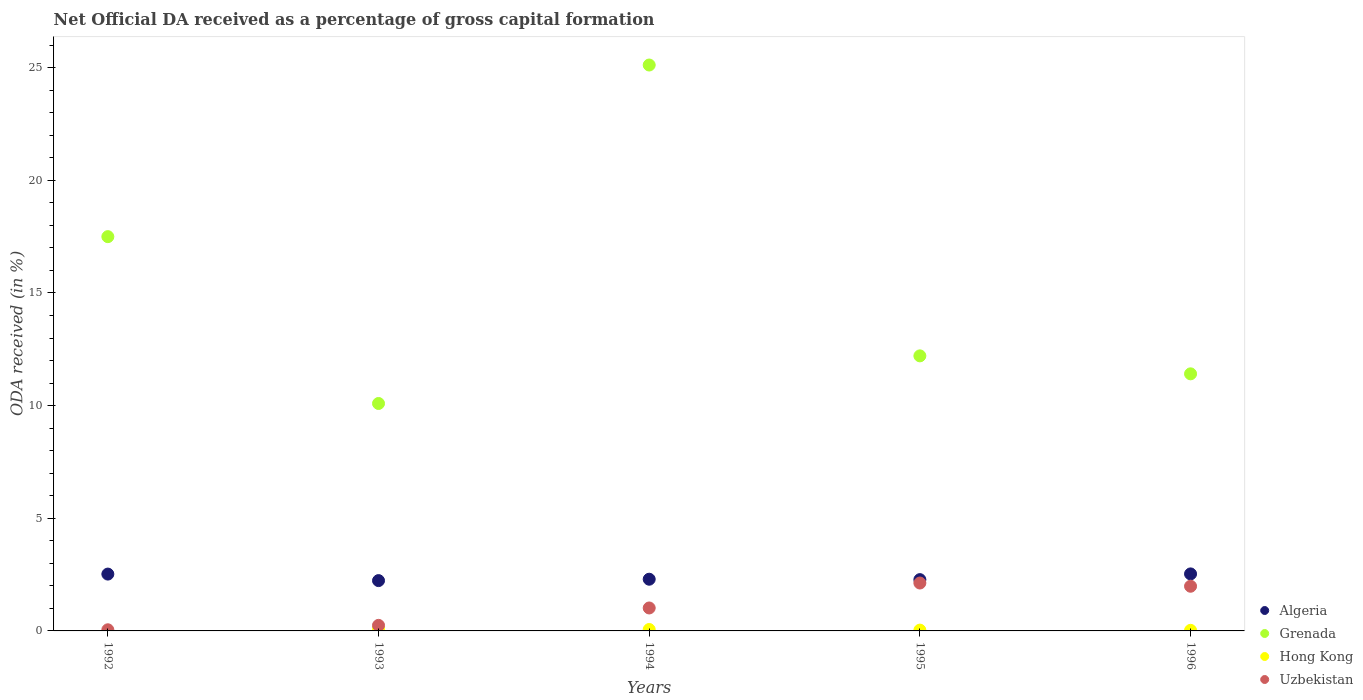Is the number of dotlines equal to the number of legend labels?
Your answer should be compact. No. What is the net ODA received in Uzbekistan in 1994?
Your response must be concise. 1.02. Across all years, what is the maximum net ODA received in Grenada?
Keep it short and to the point. 25.12. Across all years, what is the minimum net ODA received in Grenada?
Offer a terse response. 10.09. In which year was the net ODA received in Hong Kong maximum?
Give a very brief answer. 1993. What is the total net ODA received in Hong Kong in the graph?
Your answer should be compact. 0.22. What is the difference between the net ODA received in Uzbekistan in 1992 and that in 1995?
Provide a short and direct response. -2.08. What is the difference between the net ODA received in Grenada in 1993 and the net ODA received in Hong Kong in 1996?
Make the answer very short. 10.07. What is the average net ODA received in Uzbekistan per year?
Offer a very short reply. 1.08. In the year 1995, what is the difference between the net ODA received in Grenada and net ODA received in Uzbekistan?
Ensure brevity in your answer.  10.08. In how many years, is the net ODA received in Algeria greater than 25 %?
Your answer should be compact. 0. What is the ratio of the net ODA received in Grenada in 1992 to that in 1994?
Keep it short and to the point. 0.7. Is the net ODA received in Algeria in 1995 less than that in 1996?
Provide a succinct answer. Yes. Is the difference between the net ODA received in Grenada in 1993 and 1996 greater than the difference between the net ODA received in Uzbekistan in 1993 and 1996?
Give a very brief answer. Yes. What is the difference between the highest and the second highest net ODA received in Uzbekistan?
Offer a terse response. 0.14. What is the difference between the highest and the lowest net ODA received in Uzbekistan?
Make the answer very short. 2.08. Is the sum of the net ODA received in Uzbekistan in 1993 and 1995 greater than the maximum net ODA received in Hong Kong across all years?
Ensure brevity in your answer.  Yes. Is it the case that in every year, the sum of the net ODA received in Algeria and net ODA received in Hong Kong  is greater than the sum of net ODA received in Uzbekistan and net ODA received in Grenada?
Keep it short and to the point. Yes. Is it the case that in every year, the sum of the net ODA received in Algeria and net ODA received in Grenada  is greater than the net ODA received in Hong Kong?
Offer a very short reply. Yes. Is the net ODA received in Algeria strictly greater than the net ODA received in Grenada over the years?
Keep it short and to the point. No. How many years are there in the graph?
Your response must be concise. 5. What is the difference between two consecutive major ticks on the Y-axis?
Offer a very short reply. 5. Are the values on the major ticks of Y-axis written in scientific E-notation?
Keep it short and to the point. No. Does the graph contain any zero values?
Make the answer very short. Yes. What is the title of the graph?
Give a very brief answer. Net Official DA received as a percentage of gross capital formation. What is the label or title of the X-axis?
Make the answer very short. Years. What is the label or title of the Y-axis?
Your answer should be compact. ODA received (in %). What is the ODA received (in %) in Algeria in 1992?
Give a very brief answer. 2.52. What is the ODA received (in %) in Grenada in 1992?
Give a very brief answer. 17.5. What is the ODA received (in %) in Uzbekistan in 1992?
Ensure brevity in your answer.  0.05. What is the ODA received (in %) in Algeria in 1993?
Your response must be concise. 2.23. What is the ODA received (in %) of Grenada in 1993?
Your answer should be compact. 10.09. What is the ODA received (in %) in Hong Kong in 1993?
Make the answer very short. 0.09. What is the ODA received (in %) of Uzbekistan in 1993?
Give a very brief answer. 0.25. What is the ODA received (in %) in Algeria in 1994?
Ensure brevity in your answer.  2.29. What is the ODA received (in %) in Grenada in 1994?
Make the answer very short. 25.12. What is the ODA received (in %) in Hong Kong in 1994?
Ensure brevity in your answer.  0.06. What is the ODA received (in %) of Uzbekistan in 1994?
Ensure brevity in your answer.  1.02. What is the ODA received (in %) of Algeria in 1995?
Keep it short and to the point. 2.28. What is the ODA received (in %) in Grenada in 1995?
Ensure brevity in your answer.  12.21. What is the ODA received (in %) in Hong Kong in 1995?
Keep it short and to the point. 0.04. What is the ODA received (in %) in Uzbekistan in 1995?
Offer a terse response. 2.13. What is the ODA received (in %) of Algeria in 1996?
Give a very brief answer. 2.53. What is the ODA received (in %) in Grenada in 1996?
Give a very brief answer. 11.41. What is the ODA received (in %) of Hong Kong in 1996?
Ensure brevity in your answer.  0.03. What is the ODA received (in %) of Uzbekistan in 1996?
Provide a succinct answer. 1.98. Across all years, what is the maximum ODA received (in %) of Algeria?
Make the answer very short. 2.53. Across all years, what is the maximum ODA received (in %) of Grenada?
Your answer should be very brief. 25.12. Across all years, what is the maximum ODA received (in %) of Hong Kong?
Provide a short and direct response. 0.09. Across all years, what is the maximum ODA received (in %) in Uzbekistan?
Your answer should be very brief. 2.13. Across all years, what is the minimum ODA received (in %) of Algeria?
Keep it short and to the point. 2.23. Across all years, what is the minimum ODA received (in %) of Grenada?
Provide a succinct answer. 10.09. Across all years, what is the minimum ODA received (in %) in Hong Kong?
Keep it short and to the point. 0. Across all years, what is the minimum ODA received (in %) in Uzbekistan?
Ensure brevity in your answer.  0.05. What is the total ODA received (in %) of Algeria in the graph?
Provide a short and direct response. 11.86. What is the total ODA received (in %) of Grenada in the graph?
Your answer should be compact. 76.33. What is the total ODA received (in %) of Hong Kong in the graph?
Keep it short and to the point. 0.22. What is the total ODA received (in %) in Uzbekistan in the graph?
Provide a short and direct response. 5.42. What is the difference between the ODA received (in %) of Algeria in 1992 and that in 1993?
Your answer should be very brief. 0.29. What is the difference between the ODA received (in %) in Grenada in 1992 and that in 1993?
Your answer should be compact. 7.4. What is the difference between the ODA received (in %) in Uzbekistan in 1992 and that in 1993?
Give a very brief answer. -0.2. What is the difference between the ODA received (in %) of Algeria in 1992 and that in 1994?
Keep it short and to the point. 0.23. What is the difference between the ODA received (in %) in Grenada in 1992 and that in 1994?
Give a very brief answer. -7.62. What is the difference between the ODA received (in %) of Uzbekistan in 1992 and that in 1994?
Provide a short and direct response. -0.97. What is the difference between the ODA received (in %) in Algeria in 1992 and that in 1995?
Keep it short and to the point. 0.25. What is the difference between the ODA received (in %) in Grenada in 1992 and that in 1995?
Offer a very short reply. 5.29. What is the difference between the ODA received (in %) in Uzbekistan in 1992 and that in 1995?
Make the answer very short. -2.08. What is the difference between the ODA received (in %) of Algeria in 1992 and that in 1996?
Provide a short and direct response. -0.01. What is the difference between the ODA received (in %) of Grenada in 1992 and that in 1996?
Your response must be concise. 6.09. What is the difference between the ODA received (in %) of Uzbekistan in 1992 and that in 1996?
Your response must be concise. -1.93. What is the difference between the ODA received (in %) in Algeria in 1993 and that in 1994?
Provide a short and direct response. -0.06. What is the difference between the ODA received (in %) in Grenada in 1993 and that in 1994?
Ensure brevity in your answer.  -15.02. What is the difference between the ODA received (in %) of Hong Kong in 1993 and that in 1994?
Your response must be concise. 0.03. What is the difference between the ODA received (in %) of Uzbekistan in 1993 and that in 1994?
Your answer should be very brief. -0.77. What is the difference between the ODA received (in %) of Algeria in 1993 and that in 1995?
Your response must be concise. -0.04. What is the difference between the ODA received (in %) of Grenada in 1993 and that in 1995?
Your answer should be compact. -2.11. What is the difference between the ODA received (in %) in Hong Kong in 1993 and that in 1995?
Offer a terse response. 0.06. What is the difference between the ODA received (in %) in Uzbekistan in 1993 and that in 1995?
Keep it short and to the point. -1.88. What is the difference between the ODA received (in %) in Algeria in 1993 and that in 1996?
Ensure brevity in your answer.  -0.3. What is the difference between the ODA received (in %) in Grenada in 1993 and that in 1996?
Provide a succinct answer. -1.32. What is the difference between the ODA received (in %) in Hong Kong in 1993 and that in 1996?
Give a very brief answer. 0.07. What is the difference between the ODA received (in %) in Uzbekistan in 1993 and that in 1996?
Offer a terse response. -1.74. What is the difference between the ODA received (in %) in Algeria in 1994 and that in 1995?
Ensure brevity in your answer.  0.02. What is the difference between the ODA received (in %) in Grenada in 1994 and that in 1995?
Provide a succinct answer. 12.91. What is the difference between the ODA received (in %) of Hong Kong in 1994 and that in 1995?
Make the answer very short. 0.03. What is the difference between the ODA received (in %) of Uzbekistan in 1994 and that in 1995?
Give a very brief answer. -1.11. What is the difference between the ODA received (in %) of Algeria in 1994 and that in 1996?
Ensure brevity in your answer.  -0.24. What is the difference between the ODA received (in %) of Grenada in 1994 and that in 1996?
Make the answer very short. 13.71. What is the difference between the ODA received (in %) in Hong Kong in 1994 and that in 1996?
Your answer should be compact. 0.04. What is the difference between the ODA received (in %) of Uzbekistan in 1994 and that in 1996?
Your answer should be compact. -0.96. What is the difference between the ODA received (in %) of Algeria in 1995 and that in 1996?
Give a very brief answer. -0.25. What is the difference between the ODA received (in %) of Grenada in 1995 and that in 1996?
Your answer should be compact. 0.8. What is the difference between the ODA received (in %) of Hong Kong in 1995 and that in 1996?
Offer a terse response. 0.01. What is the difference between the ODA received (in %) of Uzbekistan in 1995 and that in 1996?
Your answer should be compact. 0.14. What is the difference between the ODA received (in %) in Algeria in 1992 and the ODA received (in %) in Grenada in 1993?
Your answer should be compact. -7.57. What is the difference between the ODA received (in %) of Algeria in 1992 and the ODA received (in %) of Hong Kong in 1993?
Ensure brevity in your answer.  2.43. What is the difference between the ODA received (in %) of Algeria in 1992 and the ODA received (in %) of Uzbekistan in 1993?
Make the answer very short. 2.28. What is the difference between the ODA received (in %) of Grenada in 1992 and the ODA received (in %) of Hong Kong in 1993?
Offer a very short reply. 17.41. What is the difference between the ODA received (in %) of Grenada in 1992 and the ODA received (in %) of Uzbekistan in 1993?
Offer a very short reply. 17.25. What is the difference between the ODA received (in %) in Algeria in 1992 and the ODA received (in %) in Grenada in 1994?
Ensure brevity in your answer.  -22.59. What is the difference between the ODA received (in %) in Algeria in 1992 and the ODA received (in %) in Hong Kong in 1994?
Ensure brevity in your answer.  2.46. What is the difference between the ODA received (in %) of Algeria in 1992 and the ODA received (in %) of Uzbekistan in 1994?
Offer a very short reply. 1.5. What is the difference between the ODA received (in %) of Grenada in 1992 and the ODA received (in %) of Hong Kong in 1994?
Offer a very short reply. 17.44. What is the difference between the ODA received (in %) in Grenada in 1992 and the ODA received (in %) in Uzbekistan in 1994?
Keep it short and to the point. 16.48. What is the difference between the ODA received (in %) of Algeria in 1992 and the ODA received (in %) of Grenada in 1995?
Keep it short and to the point. -9.69. What is the difference between the ODA received (in %) in Algeria in 1992 and the ODA received (in %) in Hong Kong in 1995?
Provide a succinct answer. 2.49. What is the difference between the ODA received (in %) of Algeria in 1992 and the ODA received (in %) of Uzbekistan in 1995?
Ensure brevity in your answer.  0.4. What is the difference between the ODA received (in %) of Grenada in 1992 and the ODA received (in %) of Hong Kong in 1995?
Provide a succinct answer. 17.46. What is the difference between the ODA received (in %) in Grenada in 1992 and the ODA received (in %) in Uzbekistan in 1995?
Give a very brief answer. 15.37. What is the difference between the ODA received (in %) in Algeria in 1992 and the ODA received (in %) in Grenada in 1996?
Ensure brevity in your answer.  -8.89. What is the difference between the ODA received (in %) of Algeria in 1992 and the ODA received (in %) of Hong Kong in 1996?
Give a very brief answer. 2.5. What is the difference between the ODA received (in %) in Algeria in 1992 and the ODA received (in %) in Uzbekistan in 1996?
Provide a short and direct response. 0.54. What is the difference between the ODA received (in %) in Grenada in 1992 and the ODA received (in %) in Hong Kong in 1996?
Offer a terse response. 17.47. What is the difference between the ODA received (in %) in Grenada in 1992 and the ODA received (in %) in Uzbekistan in 1996?
Offer a terse response. 15.52. What is the difference between the ODA received (in %) in Algeria in 1993 and the ODA received (in %) in Grenada in 1994?
Ensure brevity in your answer.  -22.88. What is the difference between the ODA received (in %) in Algeria in 1993 and the ODA received (in %) in Hong Kong in 1994?
Provide a short and direct response. 2.17. What is the difference between the ODA received (in %) of Algeria in 1993 and the ODA received (in %) of Uzbekistan in 1994?
Keep it short and to the point. 1.21. What is the difference between the ODA received (in %) in Grenada in 1993 and the ODA received (in %) in Hong Kong in 1994?
Your response must be concise. 10.03. What is the difference between the ODA received (in %) in Grenada in 1993 and the ODA received (in %) in Uzbekistan in 1994?
Keep it short and to the point. 9.08. What is the difference between the ODA received (in %) of Hong Kong in 1993 and the ODA received (in %) of Uzbekistan in 1994?
Provide a short and direct response. -0.93. What is the difference between the ODA received (in %) of Algeria in 1993 and the ODA received (in %) of Grenada in 1995?
Give a very brief answer. -9.97. What is the difference between the ODA received (in %) in Algeria in 1993 and the ODA received (in %) in Hong Kong in 1995?
Make the answer very short. 2.2. What is the difference between the ODA received (in %) in Algeria in 1993 and the ODA received (in %) in Uzbekistan in 1995?
Ensure brevity in your answer.  0.11. What is the difference between the ODA received (in %) of Grenada in 1993 and the ODA received (in %) of Hong Kong in 1995?
Offer a terse response. 10.06. What is the difference between the ODA received (in %) of Grenada in 1993 and the ODA received (in %) of Uzbekistan in 1995?
Keep it short and to the point. 7.97. What is the difference between the ODA received (in %) of Hong Kong in 1993 and the ODA received (in %) of Uzbekistan in 1995?
Provide a succinct answer. -2.03. What is the difference between the ODA received (in %) in Algeria in 1993 and the ODA received (in %) in Grenada in 1996?
Your answer should be very brief. -9.18. What is the difference between the ODA received (in %) of Algeria in 1993 and the ODA received (in %) of Hong Kong in 1996?
Make the answer very short. 2.21. What is the difference between the ODA received (in %) in Grenada in 1993 and the ODA received (in %) in Hong Kong in 1996?
Give a very brief answer. 10.07. What is the difference between the ODA received (in %) in Grenada in 1993 and the ODA received (in %) in Uzbekistan in 1996?
Keep it short and to the point. 8.11. What is the difference between the ODA received (in %) in Hong Kong in 1993 and the ODA received (in %) in Uzbekistan in 1996?
Provide a succinct answer. -1.89. What is the difference between the ODA received (in %) in Algeria in 1994 and the ODA received (in %) in Grenada in 1995?
Ensure brevity in your answer.  -9.91. What is the difference between the ODA received (in %) in Algeria in 1994 and the ODA received (in %) in Hong Kong in 1995?
Your response must be concise. 2.26. What is the difference between the ODA received (in %) in Algeria in 1994 and the ODA received (in %) in Uzbekistan in 1995?
Your answer should be very brief. 0.17. What is the difference between the ODA received (in %) in Grenada in 1994 and the ODA received (in %) in Hong Kong in 1995?
Give a very brief answer. 25.08. What is the difference between the ODA received (in %) in Grenada in 1994 and the ODA received (in %) in Uzbekistan in 1995?
Your answer should be compact. 22.99. What is the difference between the ODA received (in %) of Hong Kong in 1994 and the ODA received (in %) of Uzbekistan in 1995?
Offer a very short reply. -2.06. What is the difference between the ODA received (in %) of Algeria in 1994 and the ODA received (in %) of Grenada in 1996?
Provide a short and direct response. -9.12. What is the difference between the ODA received (in %) in Algeria in 1994 and the ODA received (in %) in Hong Kong in 1996?
Make the answer very short. 2.27. What is the difference between the ODA received (in %) of Algeria in 1994 and the ODA received (in %) of Uzbekistan in 1996?
Keep it short and to the point. 0.31. What is the difference between the ODA received (in %) in Grenada in 1994 and the ODA received (in %) in Hong Kong in 1996?
Your response must be concise. 25.09. What is the difference between the ODA received (in %) of Grenada in 1994 and the ODA received (in %) of Uzbekistan in 1996?
Give a very brief answer. 23.13. What is the difference between the ODA received (in %) of Hong Kong in 1994 and the ODA received (in %) of Uzbekistan in 1996?
Give a very brief answer. -1.92. What is the difference between the ODA received (in %) of Algeria in 1995 and the ODA received (in %) of Grenada in 1996?
Provide a short and direct response. -9.13. What is the difference between the ODA received (in %) of Algeria in 1995 and the ODA received (in %) of Hong Kong in 1996?
Offer a terse response. 2.25. What is the difference between the ODA received (in %) in Algeria in 1995 and the ODA received (in %) in Uzbekistan in 1996?
Provide a succinct answer. 0.29. What is the difference between the ODA received (in %) of Grenada in 1995 and the ODA received (in %) of Hong Kong in 1996?
Offer a terse response. 12.18. What is the difference between the ODA received (in %) of Grenada in 1995 and the ODA received (in %) of Uzbekistan in 1996?
Keep it short and to the point. 10.22. What is the difference between the ODA received (in %) of Hong Kong in 1995 and the ODA received (in %) of Uzbekistan in 1996?
Your answer should be compact. -1.95. What is the average ODA received (in %) in Algeria per year?
Make the answer very short. 2.37. What is the average ODA received (in %) in Grenada per year?
Ensure brevity in your answer.  15.27. What is the average ODA received (in %) in Hong Kong per year?
Provide a succinct answer. 0.04. What is the average ODA received (in %) of Uzbekistan per year?
Provide a short and direct response. 1.08. In the year 1992, what is the difference between the ODA received (in %) in Algeria and ODA received (in %) in Grenada?
Provide a short and direct response. -14.98. In the year 1992, what is the difference between the ODA received (in %) of Algeria and ODA received (in %) of Uzbekistan?
Give a very brief answer. 2.47. In the year 1992, what is the difference between the ODA received (in %) in Grenada and ODA received (in %) in Uzbekistan?
Offer a very short reply. 17.45. In the year 1993, what is the difference between the ODA received (in %) in Algeria and ODA received (in %) in Grenada?
Ensure brevity in your answer.  -7.86. In the year 1993, what is the difference between the ODA received (in %) in Algeria and ODA received (in %) in Hong Kong?
Your answer should be very brief. 2.14. In the year 1993, what is the difference between the ODA received (in %) of Algeria and ODA received (in %) of Uzbekistan?
Give a very brief answer. 1.99. In the year 1993, what is the difference between the ODA received (in %) in Grenada and ODA received (in %) in Hong Kong?
Ensure brevity in your answer.  10. In the year 1993, what is the difference between the ODA received (in %) of Grenada and ODA received (in %) of Uzbekistan?
Ensure brevity in your answer.  9.85. In the year 1993, what is the difference between the ODA received (in %) in Hong Kong and ODA received (in %) in Uzbekistan?
Ensure brevity in your answer.  -0.15. In the year 1994, what is the difference between the ODA received (in %) in Algeria and ODA received (in %) in Grenada?
Your response must be concise. -22.82. In the year 1994, what is the difference between the ODA received (in %) in Algeria and ODA received (in %) in Hong Kong?
Make the answer very short. 2.23. In the year 1994, what is the difference between the ODA received (in %) in Algeria and ODA received (in %) in Uzbekistan?
Make the answer very short. 1.28. In the year 1994, what is the difference between the ODA received (in %) in Grenada and ODA received (in %) in Hong Kong?
Offer a terse response. 25.05. In the year 1994, what is the difference between the ODA received (in %) in Grenada and ODA received (in %) in Uzbekistan?
Your answer should be very brief. 24.1. In the year 1994, what is the difference between the ODA received (in %) of Hong Kong and ODA received (in %) of Uzbekistan?
Your answer should be very brief. -0.96. In the year 1995, what is the difference between the ODA received (in %) in Algeria and ODA received (in %) in Grenada?
Keep it short and to the point. -9.93. In the year 1995, what is the difference between the ODA received (in %) in Algeria and ODA received (in %) in Hong Kong?
Make the answer very short. 2.24. In the year 1995, what is the difference between the ODA received (in %) of Algeria and ODA received (in %) of Uzbekistan?
Your response must be concise. 0.15. In the year 1995, what is the difference between the ODA received (in %) of Grenada and ODA received (in %) of Hong Kong?
Offer a terse response. 12.17. In the year 1995, what is the difference between the ODA received (in %) of Grenada and ODA received (in %) of Uzbekistan?
Give a very brief answer. 10.08. In the year 1995, what is the difference between the ODA received (in %) of Hong Kong and ODA received (in %) of Uzbekistan?
Keep it short and to the point. -2.09. In the year 1996, what is the difference between the ODA received (in %) of Algeria and ODA received (in %) of Grenada?
Your response must be concise. -8.88. In the year 1996, what is the difference between the ODA received (in %) of Algeria and ODA received (in %) of Hong Kong?
Offer a very short reply. 2.5. In the year 1996, what is the difference between the ODA received (in %) of Algeria and ODA received (in %) of Uzbekistan?
Make the answer very short. 0.55. In the year 1996, what is the difference between the ODA received (in %) of Grenada and ODA received (in %) of Hong Kong?
Provide a succinct answer. 11.38. In the year 1996, what is the difference between the ODA received (in %) of Grenada and ODA received (in %) of Uzbekistan?
Provide a succinct answer. 9.43. In the year 1996, what is the difference between the ODA received (in %) in Hong Kong and ODA received (in %) in Uzbekistan?
Keep it short and to the point. -1.96. What is the ratio of the ODA received (in %) of Algeria in 1992 to that in 1993?
Offer a terse response. 1.13. What is the ratio of the ODA received (in %) of Grenada in 1992 to that in 1993?
Ensure brevity in your answer.  1.73. What is the ratio of the ODA received (in %) in Uzbekistan in 1992 to that in 1993?
Make the answer very short. 0.2. What is the ratio of the ODA received (in %) of Algeria in 1992 to that in 1994?
Provide a short and direct response. 1.1. What is the ratio of the ODA received (in %) of Grenada in 1992 to that in 1994?
Your answer should be compact. 0.7. What is the ratio of the ODA received (in %) in Uzbekistan in 1992 to that in 1994?
Provide a succinct answer. 0.05. What is the ratio of the ODA received (in %) of Algeria in 1992 to that in 1995?
Your answer should be very brief. 1.11. What is the ratio of the ODA received (in %) in Grenada in 1992 to that in 1995?
Your response must be concise. 1.43. What is the ratio of the ODA received (in %) in Uzbekistan in 1992 to that in 1995?
Give a very brief answer. 0.02. What is the ratio of the ODA received (in %) in Algeria in 1992 to that in 1996?
Offer a terse response. 1. What is the ratio of the ODA received (in %) of Grenada in 1992 to that in 1996?
Offer a very short reply. 1.53. What is the ratio of the ODA received (in %) of Uzbekistan in 1992 to that in 1996?
Make the answer very short. 0.03. What is the ratio of the ODA received (in %) of Algeria in 1993 to that in 1994?
Make the answer very short. 0.97. What is the ratio of the ODA received (in %) in Grenada in 1993 to that in 1994?
Offer a very short reply. 0.4. What is the ratio of the ODA received (in %) in Hong Kong in 1993 to that in 1994?
Your answer should be compact. 1.46. What is the ratio of the ODA received (in %) of Uzbekistan in 1993 to that in 1994?
Provide a succinct answer. 0.24. What is the ratio of the ODA received (in %) in Algeria in 1993 to that in 1995?
Provide a succinct answer. 0.98. What is the ratio of the ODA received (in %) in Grenada in 1993 to that in 1995?
Make the answer very short. 0.83. What is the ratio of the ODA received (in %) of Hong Kong in 1993 to that in 1995?
Make the answer very short. 2.58. What is the ratio of the ODA received (in %) of Uzbekistan in 1993 to that in 1995?
Provide a succinct answer. 0.12. What is the ratio of the ODA received (in %) in Algeria in 1993 to that in 1996?
Your answer should be very brief. 0.88. What is the ratio of the ODA received (in %) in Grenada in 1993 to that in 1996?
Offer a terse response. 0.88. What is the ratio of the ODA received (in %) of Hong Kong in 1993 to that in 1996?
Your response must be concise. 3.55. What is the ratio of the ODA received (in %) of Uzbekistan in 1993 to that in 1996?
Offer a very short reply. 0.12. What is the ratio of the ODA received (in %) in Algeria in 1994 to that in 1995?
Keep it short and to the point. 1.01. What is the ratio of the ODA received (in %) in Grenada in 1994 to that in 1995?
Ensure brevity in your answer.  2.06. What is the ratio of the ODA received (in %) in Hong Kong in 1994 to that in 1995?
Provide a succinct answer. 1.76. What is the ratio of the ODA received (in %) of Uzbekistan in 1994 to that in 1995?
Your response must be concise. 0.48. What is the ratio of the ODA received (in %) of Algeria in 1994 to that in 1996?
Keep it short and to the point. 0.91. What is the ratio of the ODA received (in %) in Grenada in 1994 to that in 1996?
Your response must be concise. 2.2. What is the ratio of the ODA received (in %) of Hong Kong in 1994 to that in 1996?
Keep it short and to the point. 2.43. What is the ratio of the ODA received (in %) of Uzbekistan in 1994 to that in 1996?
Offer a very short reply. 0.51. What is the ratio of the ODA received (in %) in Algeria in 1995 to that in 1996?
Provide a succinct answer. 0.9. What is the ratio of the ODA received (in %) of Grenada in 1995 to that in 1996?
Provide a short and direct response. 1.07. What is the ratio of the ODA received (in %) of Hong Kong in 1995 to that in 1996?
Keep it short and to the point. 1.38. What is the ratio of the ODA received (in %) in Uzbekistan in 1995 to that in 1996?
Provide a short and direct response. 1.07. What is the difference between the highest and the second highest ODA received (in %) in Algeria?
Offer a terse response. 0.01. What is the difference between the highest and the second highest ODA received (in %) in Grenada?
Your response must be concise. 7.62. What is the difference between the highest and the second highest ODA received (in %) of Hong Kong?
Your response must be concise. 0.03. What is the difference between the highest and the second highest ODA received (in %) in Uzbekistan?
Make the answer very short. 0.14. What is the difference between the highest and the lowest ODA received (in %) in Algeria?
Your response must be concise. 0.3. What is the difference between the highest and the lowest ODA received (in %) of Grenada?
Offer a terse response. 15.02. What is the difference between the highest and the lowest ODA received (in %) of Hong Kong?
Offer a very short reply. 0.09. What is the difference between the highest and the lowest ODA received (in %) of Uzbekistan?
Offer a terse response. 2.08. 